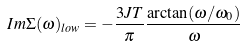<formula> <loc_0><loc_0><loc_500><loc_500>I m \Sigma ( \omega ) _ { l o w } = - \frac { 3 J T } { \pi } \frac { \arctan ( \omega / \omega _ { 0 } ) } { \omega }</formula> 